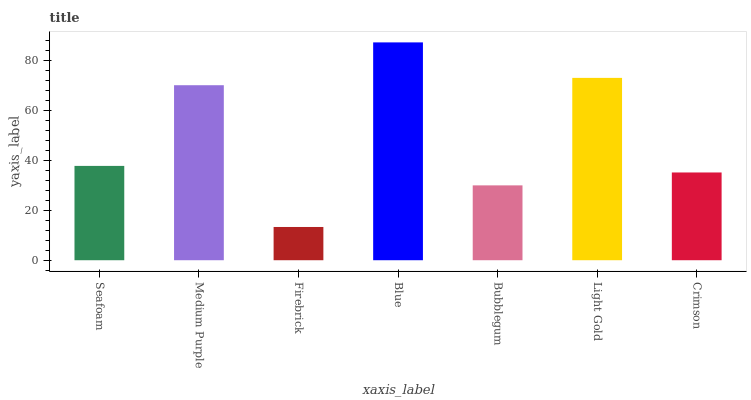Is Medium Purple the minimum?
Answer yes or no. No. Is Medium Purple the maximum?
Answer yes or no. No. Is Medium Purple greater than Seafoam?
Answer yes or no. Yes. Is Seafoam less than Medium Purple?
Answer yes or no. Yes. Is Seafoam greater than Medium Purple?
Answer yes or no. No. Is Medium Purple less than Seafoam?
Answer yes or no. No. Is Seafoam the high median?
Answer yes or no. Yes. Is Seafoam the low median?
Answer yes or no. Yes. Is Blue the high median?
Answer yes or no. No. Is Bubblegum the low median?
Answer yes or no. No. 